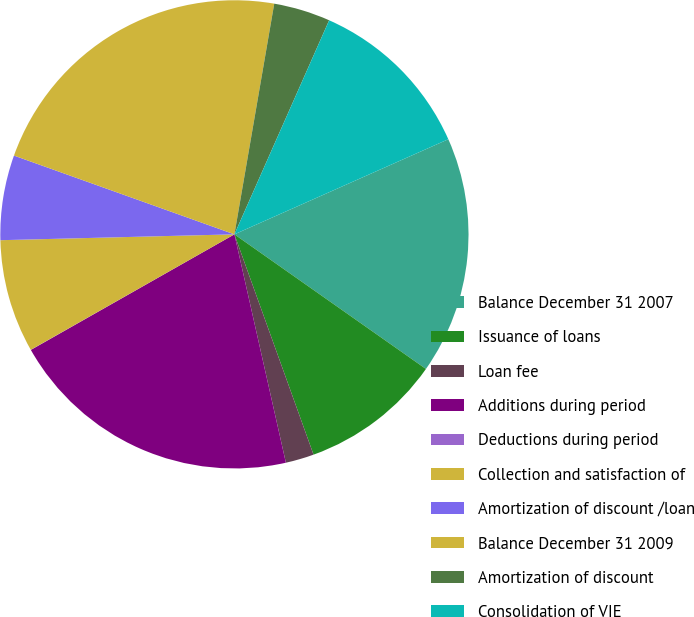Convert chart. <chart><loc_0><loc_0><loc_500><loc_500><pie_chart><fcel>Balance December 31 2007<fcel>Issuance of loans<fcel>Loan fee<fcel>Additions during period<fcel>Deductions during period<fcel>Collection and satisfaction of<fcel>Amortization of discount /loan<fcel>Balance December 31 2009<fcel>Amortization of discount<fcel>Consolidation of VIE<nl><fcel>16.41%<fcel>9.76%<fcel>1.96%<fcel>20.31%<fcel>0.01%<fcel>7.81%<fcel>5.86%<fcel>22.26%<fcel>3.91%<fcel>11.71%<nl></chart> 